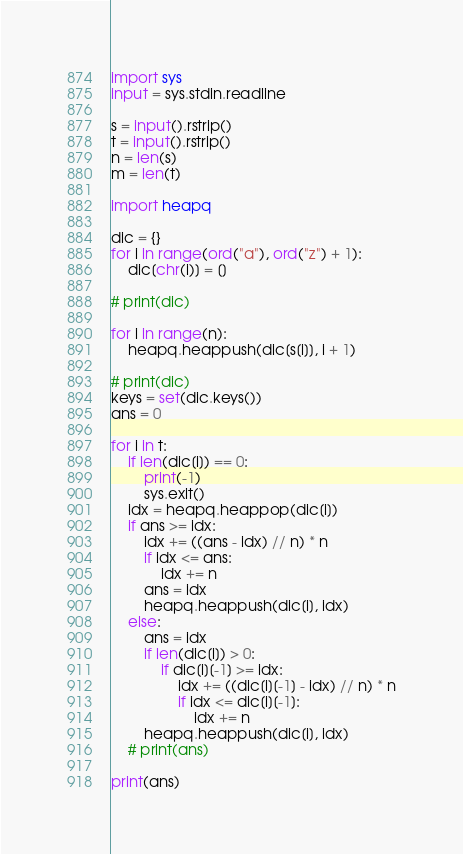<code> <loc_0><loc_0><loc_500><loc_500><_Python_>import sys
input = sys.stdin.readline

s = input().rstrip()
t = input().rstrip()
n = len(s)
m = len(t)

import heapq

dic = {}
for i in range(ord("a"), ord("z") + 1):
    dic[chr(i)] = []

# print(dic)

for i in range(n):
    heapq.heappush(dic[s[i]], i + 1)

# print(dic)
keys = set(dic.keys())
ans = 0

for i in t:
    if len(dic[i]) == 0:
        print(-1)
        sys.exit()
    idx = heapq.heappop(dic[i])
    if ans >= idx:
        idx += ((ans - idx) // n) * n
        if idx <= ans:
            idx += n
        ans = idx
        heapq.heappush(dic[i], idx)
    else:
        ans = idx
        if len(dic[i]) > 0:
            if dic[i][-1] >= idx:
                idx += ((dic[i][-1] - idx) // n) * n
                if idx <= dic[i][-1]:
                    idx += n
        heapq.heappush(dic[i], idx)
    # print(ans)

print(ans)
</code> 